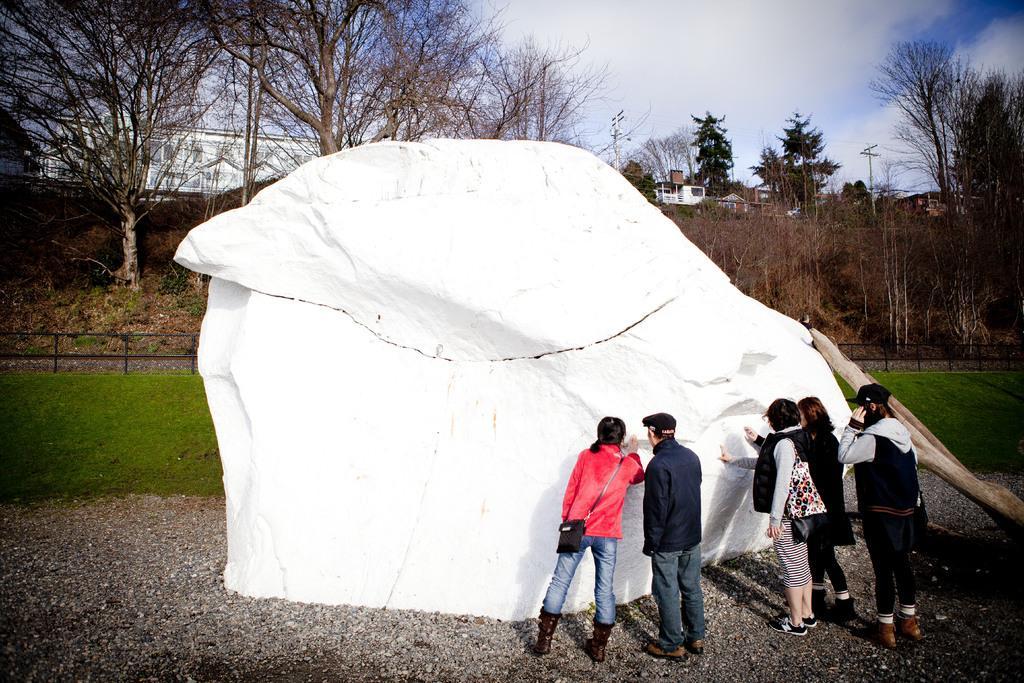Can you describe this image briefly? In this image there are people standing near a white stone, in the background there is grass,fencing, trees, buildings and a sky. 